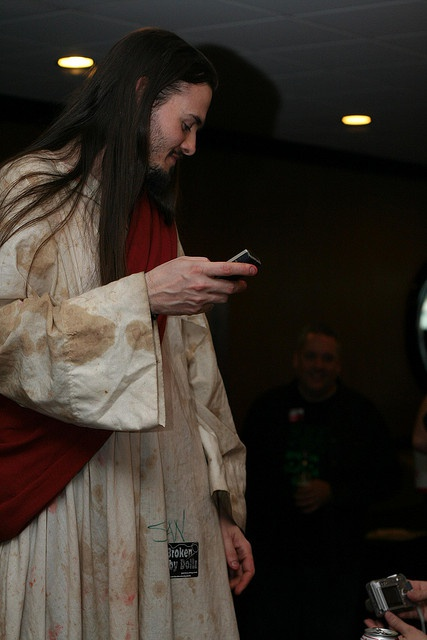Describe the objects in this image and their specific colors. I can see people in black, gray, and darkgray tones, people in black and gray tones, people in black tones, people in black, maroon, and brown tones, and cell phone in black, brown, gray, and maroon tones in this image. 